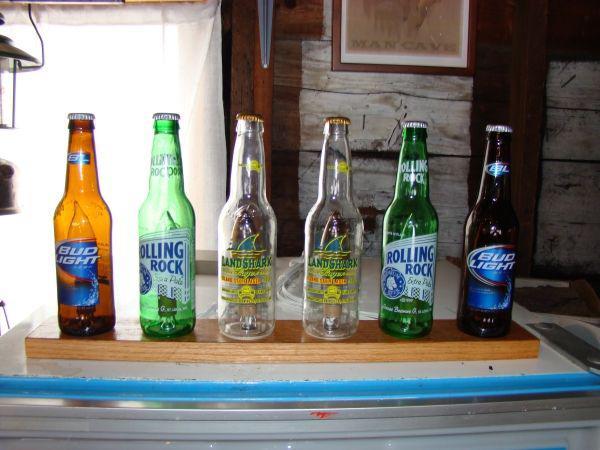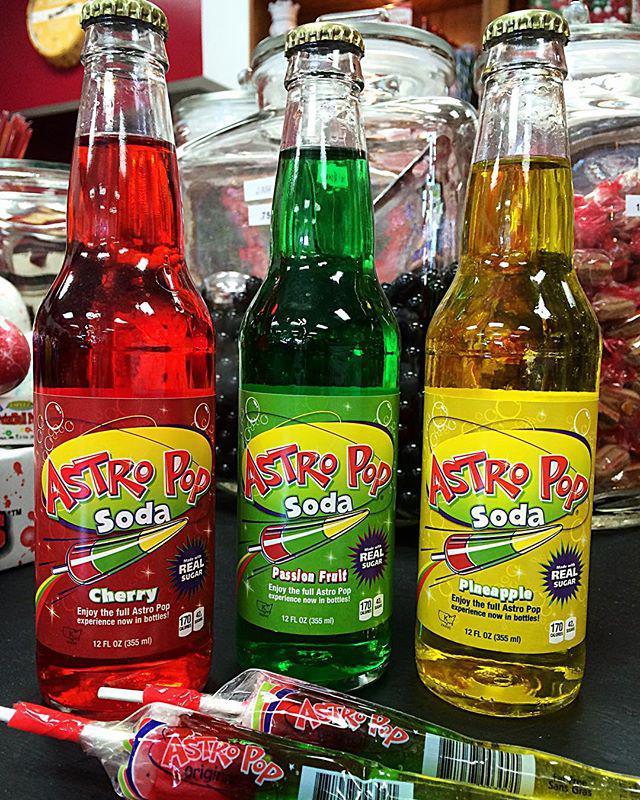The first image is the image on the left, the second image is the image on the right. Considering the images on both sides, is "There is a wall of at least four shelves full of glass bottles." valid? Answer yes or no. No. The first image is the image on the left, the second image is the image on the right. Evaluate the accuracy of this statement regarding the images: "Dozens of bottles sit on a wall shelf in one of the images.". Is it true? Answer yes or no. No. 